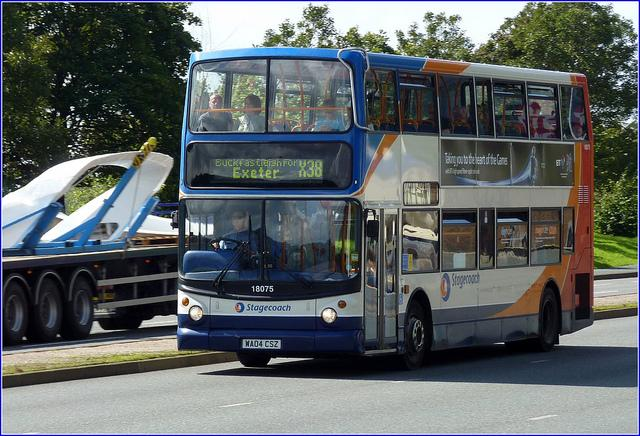In which country does this bus travel? Please explain your reasoning. england. Exeter is in england. 